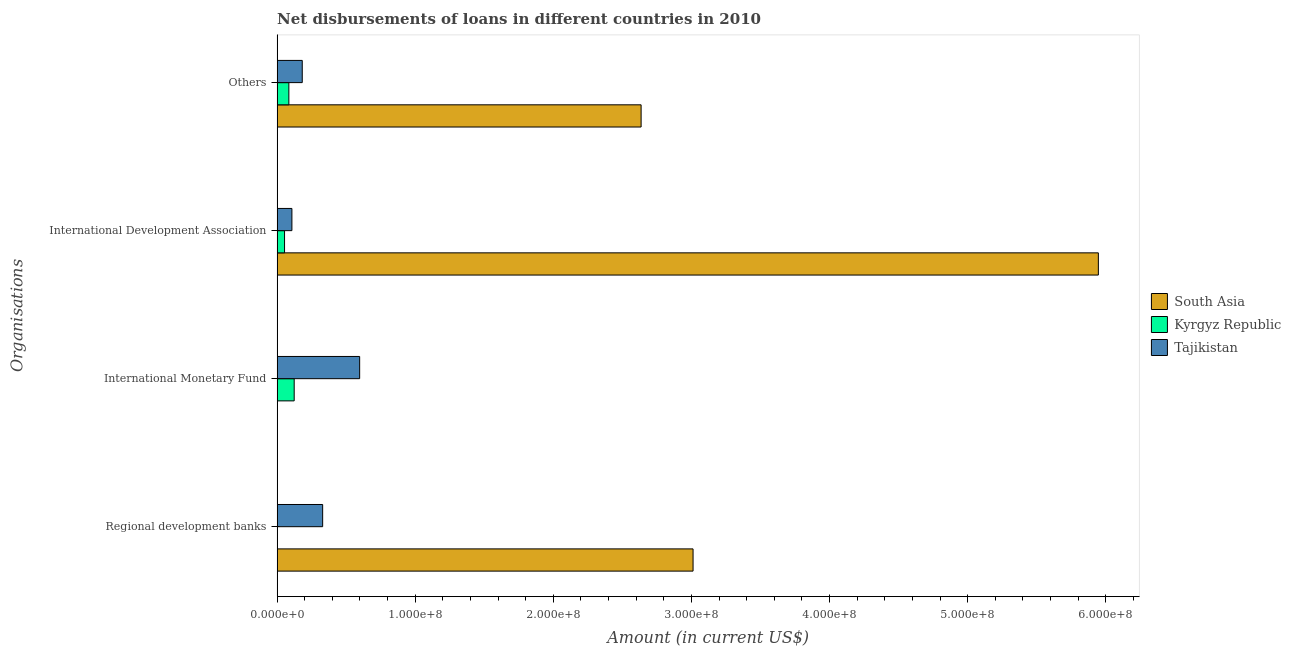How many different coloured bars are there?
Give a very brief answer. 3. Are the number of bars on each tick of the Y-axis equal?
Offer a terse response. No. What is the label of the 2nd group of bars from the top?
Offer a terse response. International Development Association. What is the amount of loan disimbursed by other organisations in Kyrgyz Republic?
Ensure brevity in your answer.  8.49e+06. Across all countries, what is the maximum amount of loan disimbursed by international monetary fund?
Give a very brief answer. 5.98e+07. Across all countries, what is the minimum amount of loan disimbursed by other organisations?
Provide a succinct answer. 8.49e+06. In which country was the amount of loan disimbursed by regional development banks maximum?
Your answer should be compact. South Asia. What is the total amount of loan disimbursed by other organisations in the graph?
Your answer should be compact. 2.90e+08. What is the difference between the amount of loan disimbursed by international monetary fund in Kyrgyz Republic and that in Tajikistan?
Ensure brevity in your answer.  -4.74e+07. What is the difference between the amount of loan disimbursed by regional development banks in Tajikistan and the amount of loan disimbursed by other organisations in Kyrgyz Republic?
Your answer should be very brief. 2.45e+07. What is the average amount of loan disimbursed by other organisations per country?
Offer a terse response. 9.67e+07. What is the difference between the amount of loan disimbursed by international development association and amount of loan disimbursed by other organisations in Tajikistan?
Make the answer very short. -7.49e+06. In how many countries, is the amount of loan disimbursed by international development association greater than 560000000 US$?
Ensure brevity in your answer.  1. What is the ratio of the amount of loan disimbursed by regional development banks in Tajikistan to that in South Asia?
Make the answer very short. 0.11. Is the difference between the amount of loan disimbursed by international monetary fund in Tajikistan and Kyrgyz Republic greater than the difference between the amount of loan disimbursed by international development association in Tajikistan and Kyrgyz Republic?
Ensure brevity in your answer.  Yes. What is the difference between the highest and the second highest amount of loan disimbursed by international development association?
Make the answer very short. 5.84e+08. What is the difference between the highest and the lowest amount of loan disimbursed by other organisations?
Keep it short and to the point. 2.55e+08. In how many countries, is the amount of loan disimbursed by regional development banks greater than the average amount of loan disimbursed by regional development banks taken over all countries?
Keep it short and to the point. 1. Is it the case that in every country, the sum of the amount of loan disimbursed by international monetary fund and amount of loan disimbursed by other organisations is greater than the sum of amount of loan disimbursed by international development association and amount of loan disimbursed by regional development banks?
Keep it short and to the point. Yes. Are all the bars in the graph horizontal?
Your answer should be compact. Yes. Does the graph contain any zero values?
Offer a very short reply. Yes. Does the graph contain grids?
Ensure brevity in your answer.  No. How many legend labels are there?
Your answer should be very brief. 3. What is the title of the graph?
Make the answer very short. Net disbursements of loans in different countries in 2010. Does "Trinidad and Tobago" appear as one of the legend labels in the graph?
Make the answer very short. No. What is the label or title of the Y-axis?
Keep it short and to the point. Organisations. What is the Amount (in current US$) in South Asia in Regional development banks?
Offer a terse response. 3.01e+08. What is the Amount (in current US$) of Kyrgyz Republic in Regional development banks?
Provide a succinct answer. 0. What is the Amount (in current US$) in Tajikistan in Regional development banks?
Offer a very short reply. 3.30e+07. What is the Amount (in current US$) of South Asia in International Monetary Fund?
Ensure brevity in your answer.  0. What is the Amount (in current US$) of Kyrgyz Republic in International Monetary Fund?
Your answer should be very brief. 1.24e+07. What is the Amount (in current US$) of Tajikistan in International Monetary Fund?
Give a very brief answer. 5.98e+07. What is the Amount (in current US$) in South Asia in International Development Association?
Your answer should be very brief. 5.95e+08. What is the Amount (in current US$) of Kyrgyz Republic in International Development Association?
Your answer should be compact. 5.38e+06. What is the Amount (in current US$) of Tajikistan in International Development Association?
Give a very brief answer. 1.07e+07. What is the Amount (in current US$) in South Asia in Others?
Make the answer very short. 2.64e+08. What is the Amount (in current US$) in Kyrgyz Republic in Others?
Offer a very short reply. 8.49e+06. What is the Amount (in current US$) in Tajikistan in Others?
Offer a terse response. 1.82e+07. Across all Organisations, what is the maximum Amount (in current US$) in South Asia?
Make the answer very short. 5.95e+08. Across all Organisations, what is the maximum Amount (in current US$) in Kyrgyz Republic?
Keep it short and to the point. 1.24e+07. Across all Organisations, what is the maximum Amount (in current US$) in Tajikistan?
Ensure brevity in your answer.  5.98e+07. Across all Organisations, what is the minimum Amount (in current US$) of South Asia?
Ensure brevity in your answer.  0. Across all Organisations, what is the minimum Amount (in current US$) of Kyrgyz Republic?
Ensure brevity in your answer.  0. Across all Organisations, what is the minimum Amount (in current US$) in Tajikistan?
Keep it short and to the point. 1.07e+07. What is the total Amount (in current US$) of South Asia in the graph?
Your answer should be compact. 1.16e+09. What is the total Amount (in current US$) of Kyrgyz Republic in the graph?
Provide a short and direct response. 2.62e+07. What is the total Amount (in current US$) of Tajikistan in the graph?
Ensure brevity in your answer.  1.22e+08. What is the difference between the Amount (in current US$) in Tajikistan in Regional development banks and that in International Monetary Fund?
Your answer should be very brief. -2.68e+07. What is the difference between the Amount (in current US$) in South Asia in Regional development banks and that in International Development Association?
Make the answer very short. -2.93e+08. What is the difference between the Amount (in current US$) of Tajikistan in Regional development banks and that in International Development Association?
Your response must be concise. 2.23e+07. What is the difference between the Amount (in current US$) in South Asia in Regional development banks and that in Others?
Keep it short and to the point. 3.76e+07. What is the difference between the Amount (in current US$) in Tajikistan in Regional development banks and that in Others?
Keep it short and to the point. 1.48e+07. What is the difference between the Amount (in current US$) in Kyrgyz Republic in International Monetary Fund and that in International Development Association?
Make the answer very short. 6.97e+06. What is the difference between the Amount (in current US$) in Tajikistan in International Monetary Fund and that in International Development Association?
Your answer should be very brief. 4.91e+07. What is the difference between the Amount (in current US$) in Kyrgyz Republic in International Monetary Fund and that in Others?
Provide a short and direct response. 3.86e+06. What is the difference between the Amount (in current US$) of Tajikistan in International Monetary Fund and that in Others?
Provide a succinct answer. 4.16e+07. What is the difference between the Amount (in current US$) in South Asia in International Development Association and that in Others?
Your answer should be very brief. 3.31e+08. What is the difference between the Amount (in current US$) in Kyrgyz Republic in International Development Association and that in Others?
Provide a succinct answer. -3.11e+06. What is the difference between the Amount (in current US$) of Tajikistan in International Development Association and that in Others?
Your response must be concise. -7.49e+06. What is the difference between the Amount (in current US$) in South Asia in Regional development banks and the Amount (in current US$) in Kyrgyz Republic in International Monetary Fund?
Offer a very short reply. 2.89e+08. What is the difference between the Amount (in current US$) in South Asia in Regional development banks and the Amount (in current US$) in Tajikistan in International Monetary Fund?
Keep it short and to the point. 2.41e+08. What is the difference between the Amount (in current US$) in South Asia in Regional development banks and the Amount (in current US$) in Kyrgyz Republic in International Development Association?
Keep it short and to the point. 2.96e+08. What is the difference between the Amount (in current US$) of South Asia in Regional development banks and the Amount (in current US$) of Tajikistan in International Development Association?
Your answer should be very brief. 2.90e+08. What is the difference between the Amount (in current US$) in South Asia in Regional development banks and the Amount (in current US$) in Kyrgyz Republic in Others?
Your answer should be very brief. 2.93e+08. What is the difference between the Amount (in current US$) of South Asia in Regional development banks and the Amount (in current US$) of Tajikistan in Others?
Your response must be concise. 2.83e+08. What is the difference between the Amount (in current US$) of Kyrgyz Republic in International Monetary Fund and the Amount (in current US$) of Tajikistan in International Development Association?
Offer a terse response. 1.65e+06. What is the difference between the Amount (in current US$) in Kyrgyz Republic in International Monetary Fund and the Amount (in current US$) in Tajikistan in Others?
Provide a succinct answer. -5.84e+06. What is the difference between the Amount (in current US$) of South Asia in International Development Association and the Amount (in current US$) of Kyrgyz Republic in Others?
Give a very brief answer. 5.86e+08. What is the difference between the Amount (in current US$) of South Asia in International Development Association and the Amount (in current US$) of Tajikistan in Others?
Give a very brief answer. 5.76e+08. What is the difference between the Amount (in current US$) in Kyrgyz Republic in International Development Association and the Amount (in current US$) in Tajikistan in Others?
Offer a terse response. -1.28e+07. What is the average Amount (in current US$) of South Asia per Organisations?
Ensure brevity in your answer.  2.90e+08. What is the average Amount (in current US$) of Kyrgyz Republic per Organisations?
Provide a succinct answer. 6.56e+06. What is the average Amount (in current US$) in Tajikistan per Organisations?
Provide a short and direct response. 3.04e+07. What is the difference between the Amount (in current US$) of South Asia and Amount (in current US$) of Tajikistan in Regional development banks?
Provide a short and direct response. 2.68e+08. What is the difference between the Amount (in current US$) of Kyrgyz Republic and Amount (in current US$) of Tajikistan in International Monetary Fund?
Ensure brevity in your answer.  -4.74e+07. What is the difference between the Amount (in current US$) in South Asia and Amount (in current US$) in Kyrgyz Republic in International Development Association?
Make the answer very short. 5.89e+08. What is the difference between the Amount (in current US$) in South Asia and Amount (in current US$) in Tajikistan in International Development Association?
Your answer should be compact. 5.84e+08. What is the difference between the Amount (in current US$) of Kyrgyz Republic and Amount (in current US$) of Tajikistan in International Development Association?
Provide a short and direct response. -5.32e+06. What is the difference between the Amount (in current US$) in South Asia and Amount (in current US$) in Kyrgyz Republic in Others?
Your answer should be compact. 2.55e+08. What is the difference between the Amount (in current US$) in South Asia and Amount (in current US$) in Tajikistan in Others?
Provide a short and direct response. 2.45e+08. What is the difference between the Amount (in current US$) of Kyrgyz Republic and Amount (in current US$) of Tajikistan in Others?
Make the answer very short. -9.70e+06. What is the ratio of the Amount (in current US$) of Tajikistan in Regional development banks to that in International Monetary Fund?
Provide a succinct answer. 0.55. What is the ratio of the Amount (in current US$) of South Asia in Regional development banks to that in International Development Association?
Make the answer very short. 0.51. What is the ratio of the Amount (in current US$) of Tajikistan in Regional development banks to that in International Development Association?
Make the answer very short. 3.08. What is the ratio of the Amount (in current US$) in South Asia in Regional development banks to that in Others?
Offer a very short reply. 1.14. What is the ratio of the Amount (in current US$) in Tajikistan in Regional development banks to that in Others?
Keep it short and to the point. 1.81. What is the ratio of the Amount (in current US$) of Kyrgyz Republic in International Monetary Fund to that in International Development Association?
Give a very brief answer. 2.3. What is the ratio of the Amount (in current US$) in Tajikistan in International Monetary Fund to that in International Development Association?
Provide a short and direct response. 5.58. What is the ratio of the Amount (in current US$) in Kyrgyz Republic in International Monetary Fund to that in Others?
Offer a terse response. 1.45. What is the ratio of the Amount (in current US$) in Tajikistan in International Monetary Fund to that in Others?
Your answer should be very brief. 3.29. What is the ratio of the Amount (in current US$) of South Asia in International Development Association to that in Others?
Make the answer very short. 2.26. What is the ratio of the Amount (in current US$) in Kyrgyz Republic in International Development Association to that in Others?
Offer a very short reply. 0.63. What is the ratio of the Amount (in current US$) of Tajikistan in International Development Association to that in Others?
Your answer should be compact. 0.59. What is the difference between the highest and the second highest Amount (in current US$) of South Asia?
Make the answer very short. 2.93e+08. What is the difference between the highest and the second highest Amount (in current US$) of Kyrgyz Republic?
Your answer should be very brief. 3.86e+06. What is the difference between the highest and the second highest Amount (in current US$) in Tajikistan?
Your answer should be very brief. 2.68e+07. What is the difference between the highest and the lowest Amount (in current US$) in South Asia?
Provide a succinct answer. 5.95e+08. What is the difference between the highest and the lowest Amount (in current US$) of Kyrgyz Republic?
Your answer should be compact. 1.24e+07. What is the difference between the highest and the lowest Amount (in current US$) of Tajikistan?
Your answer should be compact. 4.91e+07. 